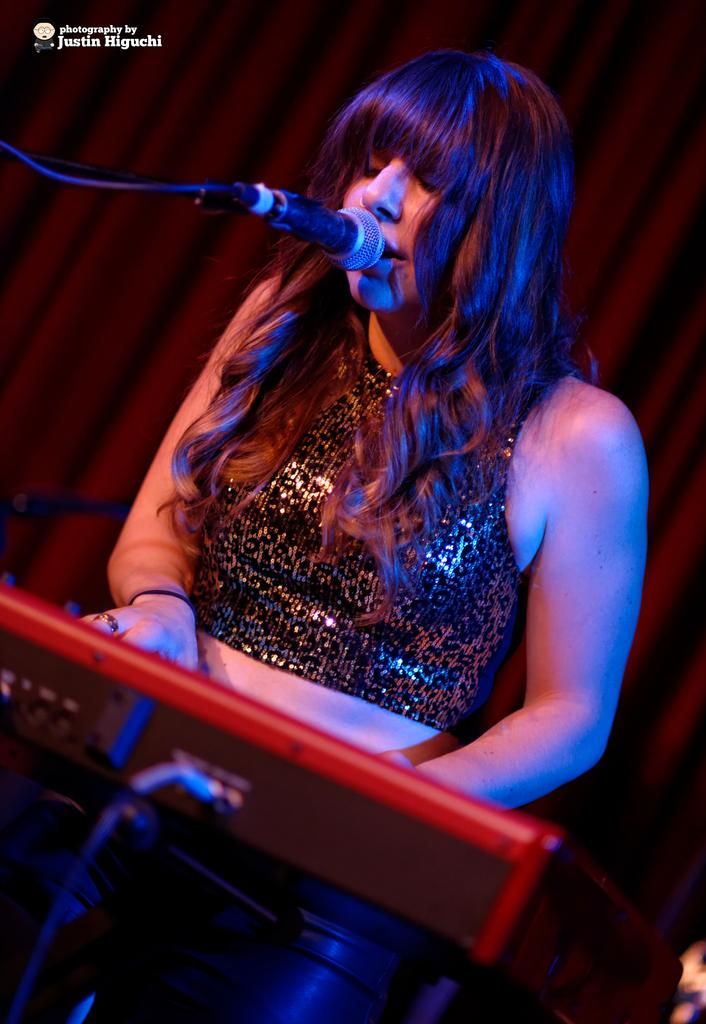Who is the main subject in the image? There is a woman in the image. What is the woman doing in the image? The woman is playing a keyboard. What object is in front of the woman? There is a microphone in front of the woman. What can be seen in the background of the image? There is a curtain in the background of the image. What type of organization is the woman a part of in the image? There is no information about any organization in the image; it only shows a woman playing a keyboard with a microphone in front of her and a curtain in the background. 